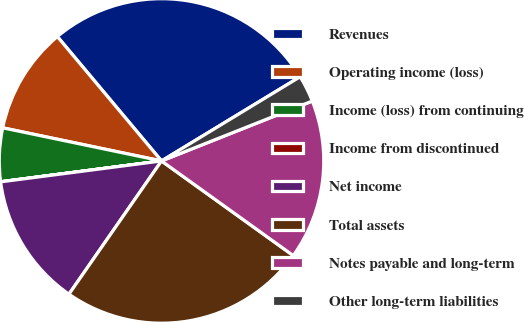Convert chart to OTSL. <chart><loc_0><loc_0><loc_500><loc_500><pie_chart><fcel>Revenues<fcel>Operating income (loss)<fcel>Income (loss) from continuing<fcel>Income from discontinued<fcel>Net income<fcel>Total assets<fcel>Notes payable and long-term<fcel>Other long-term liabilities<nl><fcel>27.41%<fcel>10.63%<fcel>5.32%<fcel>0.01%<fcel>13.28%<fcel>24.75%<fcel>15.93%<fcel>2.67%<nl></chart> 